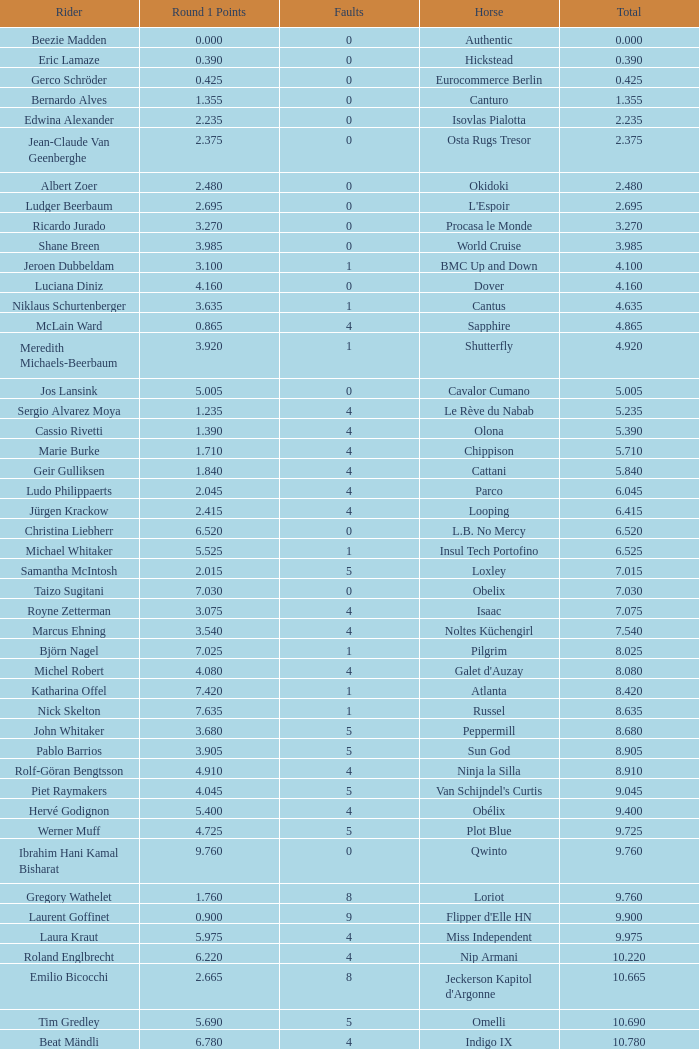Tell me the rider that had round 1 points of 7.465 and total more than 16.615 Manuel Fernandez Saro. 